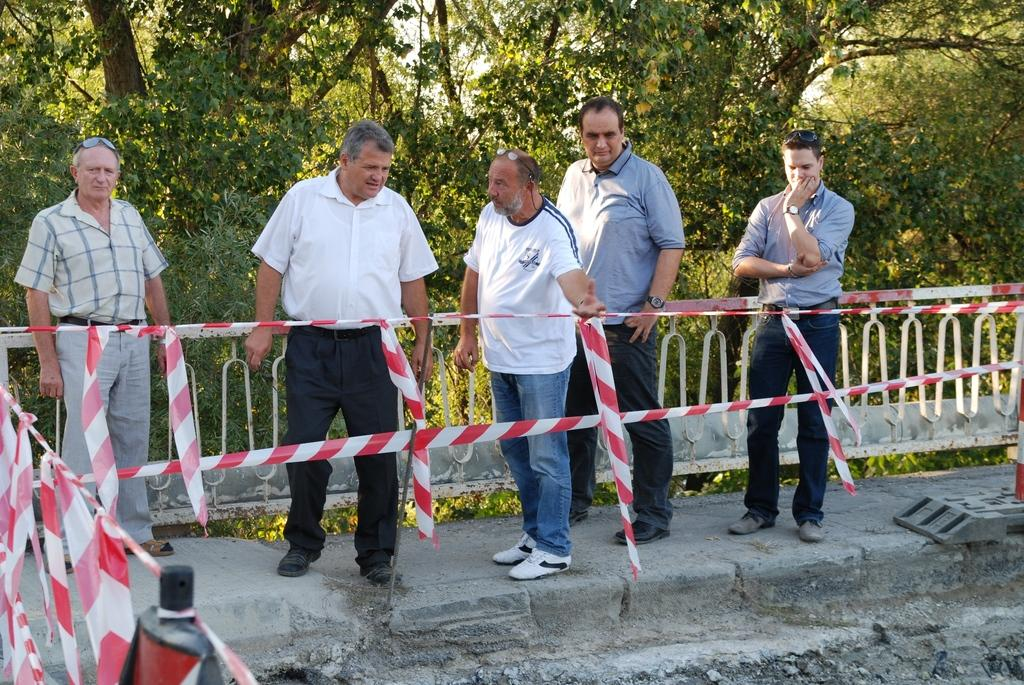How many men are in the foreground of the image? There are five men standing in the foreground of the image. What is the surface the men are standing on? The men are standing on a path. What safety feature is present in front of the men? There are safety poles in front of the men. What can be seen in the background of the image? There are trees and a railing in the background of the image. What color are the eyes of the army lawyer in the image? There is no army lawyer present in the image, and therefore no eyes to describe. 